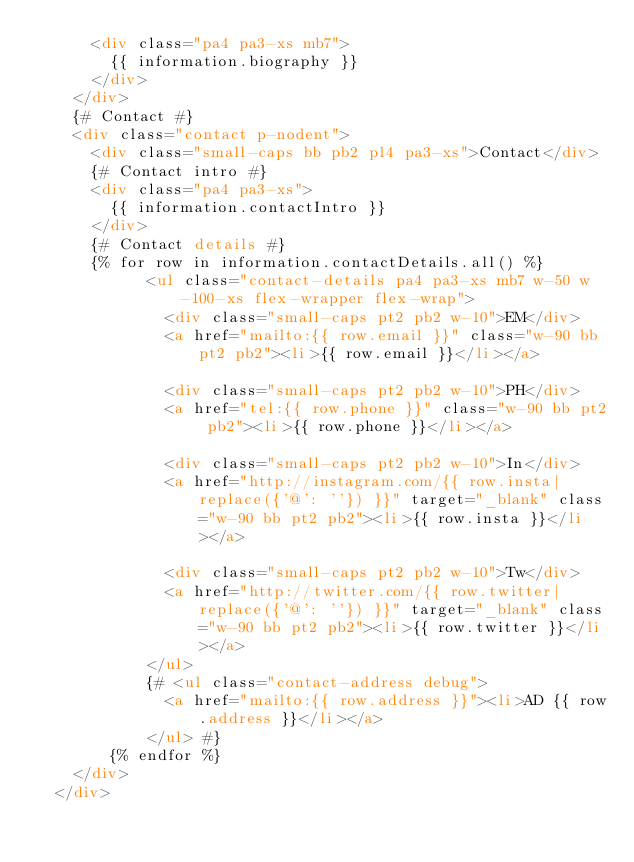<code> <loc_0><loc_0><loc_500><loc_500><_HTML_>      <div class="pa4 pa3-xs mb7">
        {{ information.biography }}
      </div>
    </div>
    {# Contact #}
    <div class="contact p-nodent">
      <div class="small-caps bb pb2 pl4 pa3-xs">Contact</div>
      {# Contact intro #}
      <div class="pa4 pa3-xs">
        {{ information.contactIntro }}
      </div>
      {# Contact details #}
      {% for row in information.contactDetails.all() %}
            <ul class="contact-details pa4 pa3-xs mb7 w-50 w-100-xs flex-wrapper flex-wrap">
              <div class="small-caps pt2 pb2 w-10">EM</div>
              <a href="mailto:{{ row.email }}" class="w-90 bb pt2 pb2"><li>{{ row.email }}</li></a>

              <div class="small-caps pt2 pb2 w-10">PH</div>
              <a href="tel:{{ row.phone }}" class="w-90 bb pt2 pb2"><li>{{ row.phone }}</li></a>

              <div class="small-caps pt2 pb2 w-10">In</div>
              <a href="http://instagram.com/{{ row.insta|replace({'@': ''}) }}" target="_blank" class="w-90 bb pt2 pb2"><li>{{ row.insta }}</li></a>

              <div class="small-caps pt2 pb2 w-10">Tw</div>
              <a href="http://twitter.com/{{ row.twitter|replace({'@': ''}) }}" target="_blank" class="w-90 bb pt2 pb2"><li>{{ row.twitter }}</li></a>
            </ul>
            {# <ul class="contact-address debug">
              <a href="mailto:{{ row.address }}"><li>AD {{ row.address }}</li></a>
            </ul> #}
        {% endfor %}
    </div>
  </div>
</code> 